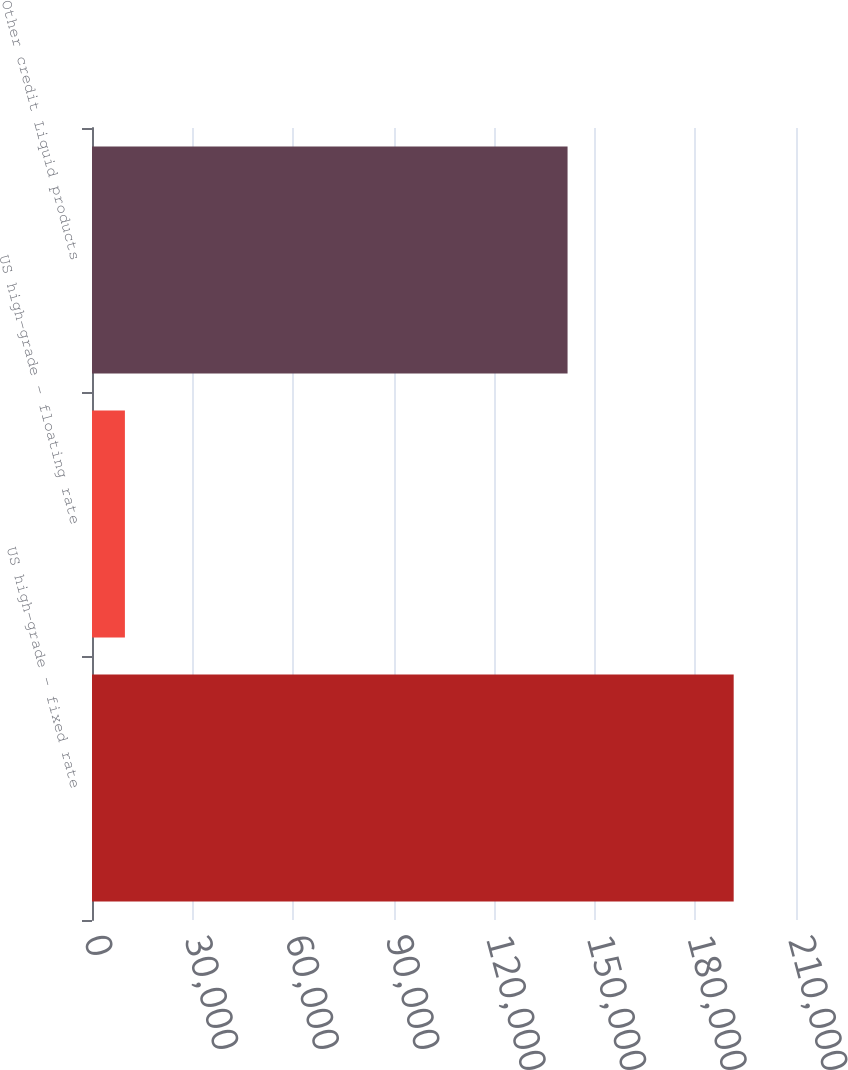<chart> <loc_0><loc_0><loc_500><loc_500><bar_chart><fcel>US high-grade - fixed rate<fcel>US high-grade - floating rate<fcel>Other credit Liquid products<nl><fcel>191411<fcel>9815<fcel>141857<nl></chart> 